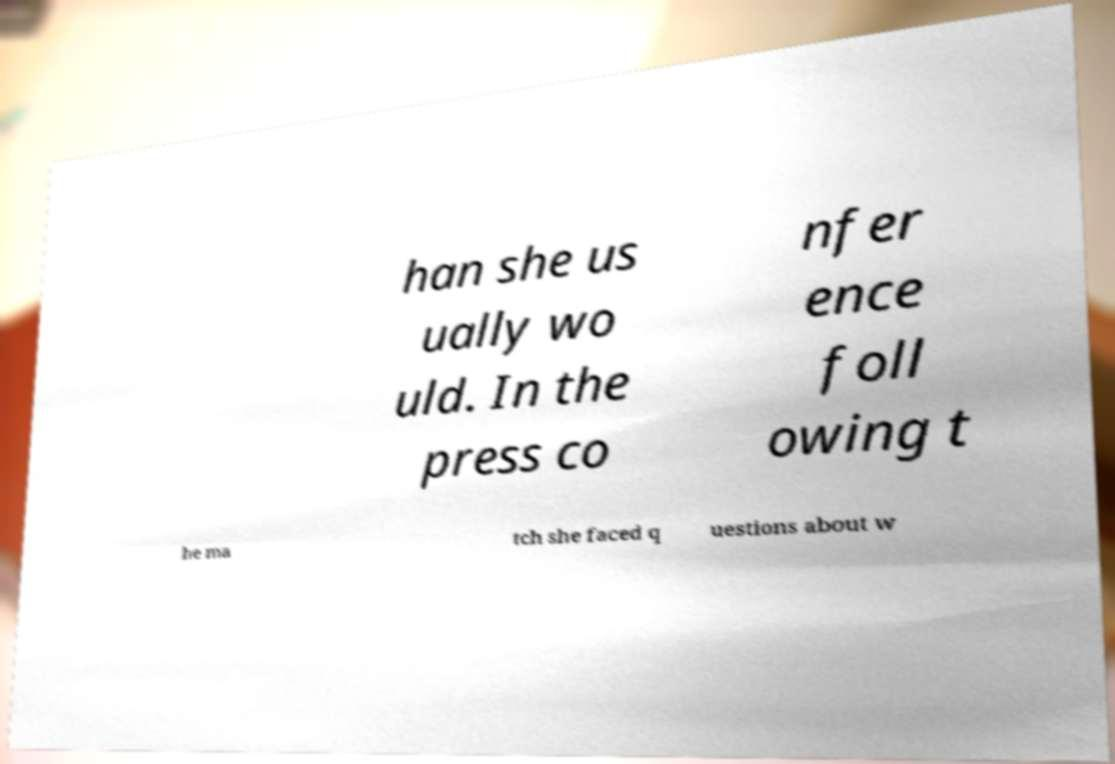Can you accurately transcribe the text from the provided image for me? han she us ually wo uld. In the press co nfer ence foll owing t he ma tch she faced q uestions about w 